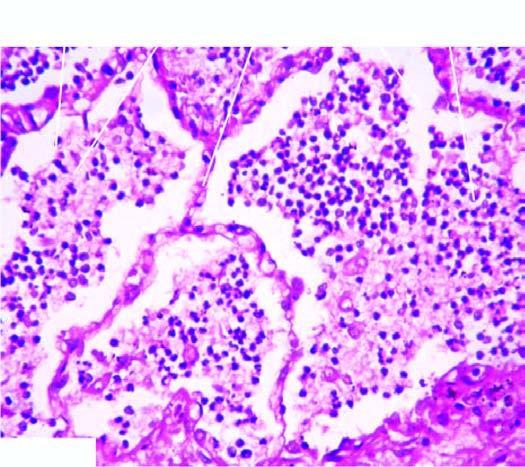what does the sectioned surface of the lung show?
Answer the question using a single word or phrase. Grey-brown 